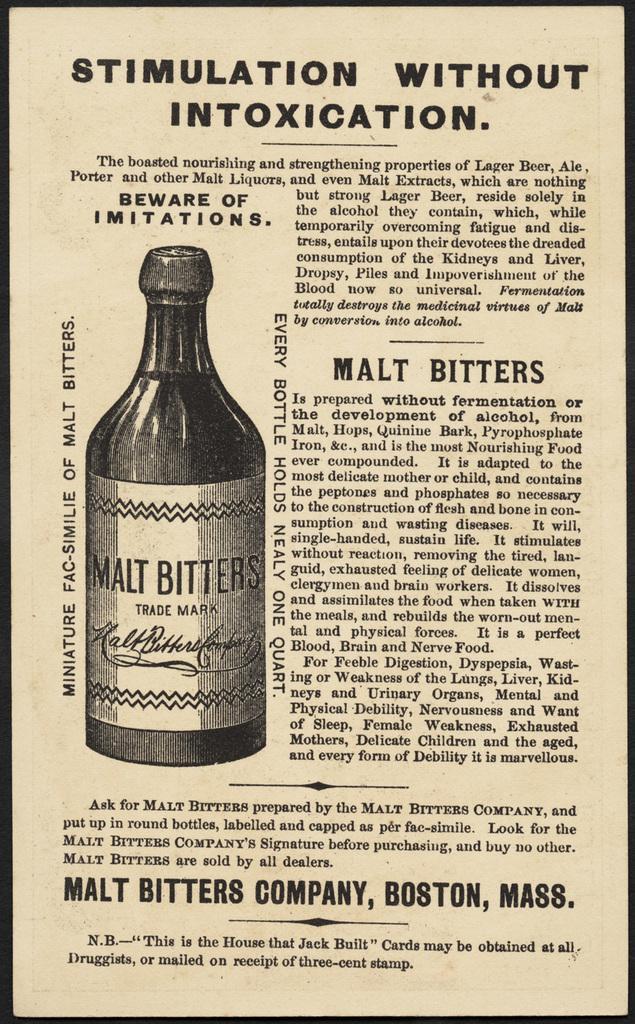How would you summarize this image in a sentence or two? The picture consists of a pamphlet. In the picture we can see text and drawing of a bottle. 